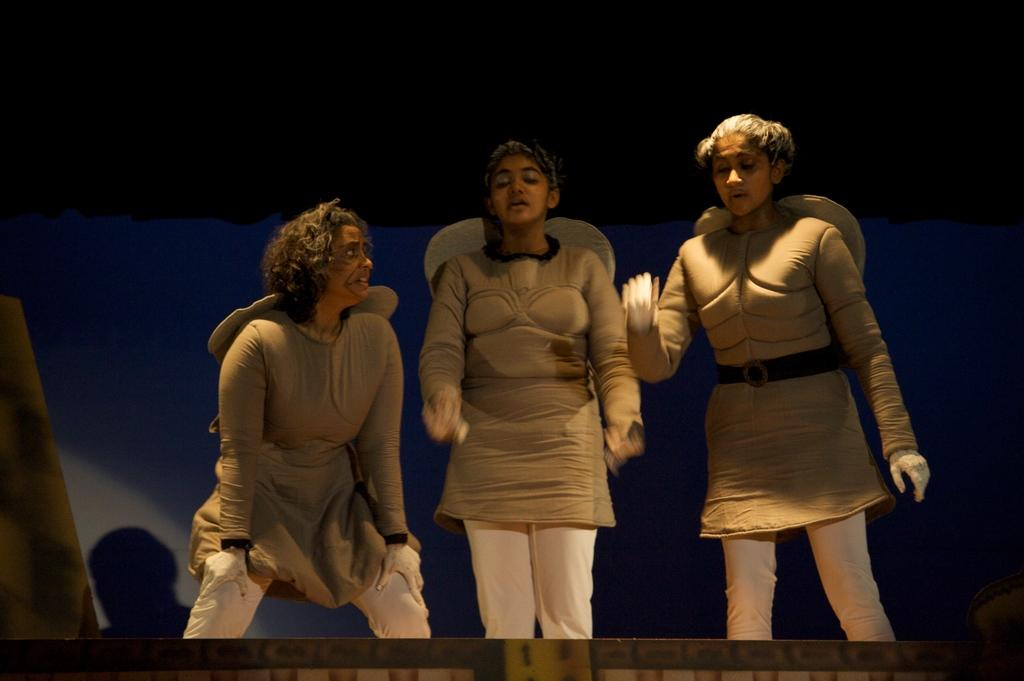How many people are in the image? There are three people in the image. What are the people doing in the image? The people are standing in the image. What are the people wearing in the image? The people are wearing costumes in the image. What is the color of the background in the image? The background of the image is white. What type of force can be seen pushing the people in the image? There is no force pushing the people in the image; they are standing on their own. What is located on top of the people in the image? There is nothing on top of the people in the image; they are standing without any objects on their heads. 